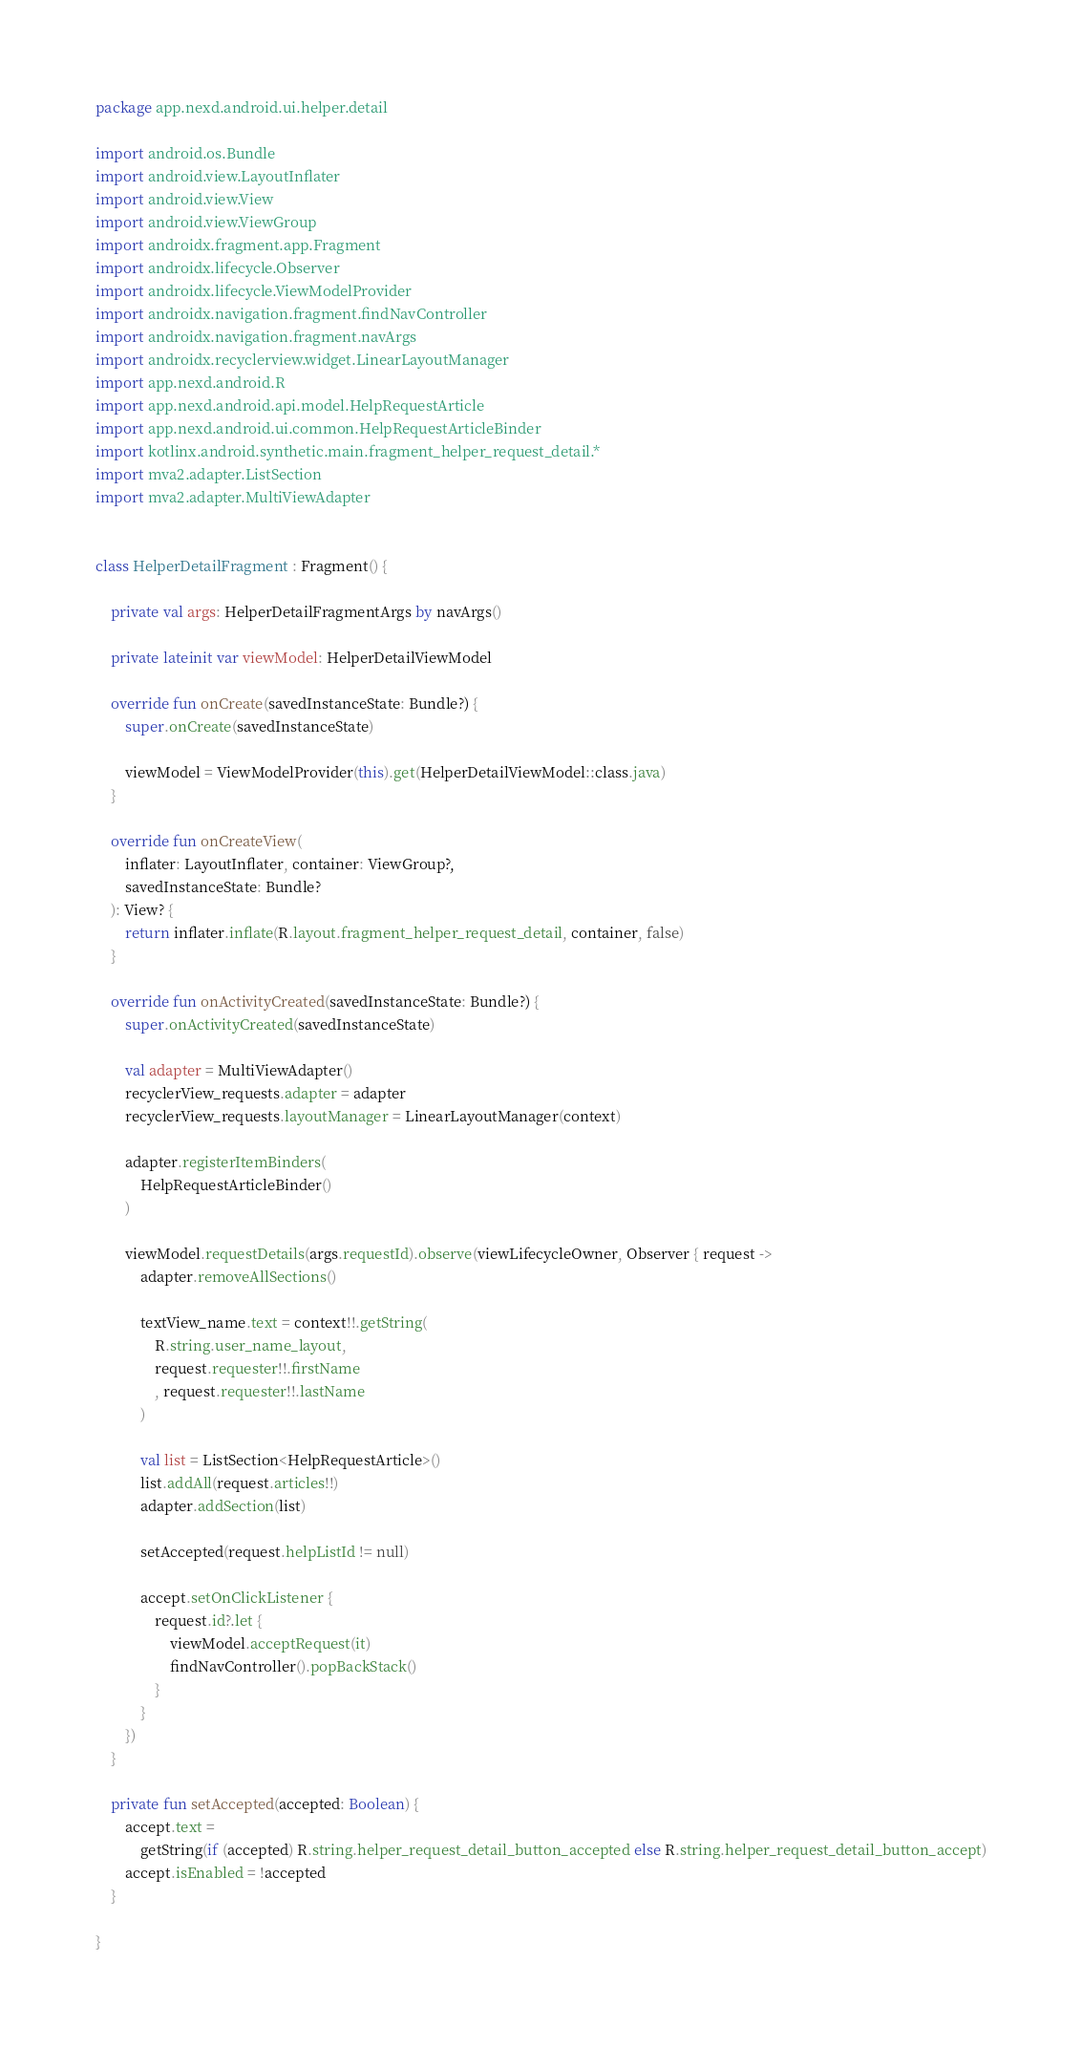<code> <loc_0><loc_0><loc_500><loc_500><_Kotlin_>package app.nexd.android.ui.helper.detail

import android.os.Bundle
import android.view.LayoutInflater
import android.view.View
import android.view.ViewGroup
import androidx.fragment.app.Fragment
import androidx.lifecycle.Observer
import androidx.lifecycle.ViewModelProvider
import androidx.navigation.fragment.findNavController
import androidx.navigation.fragment.navArgs
import androidx.recyclerview.widget.LinearLayoutManager
import app.nexd.android.R
import app.nexd.android.api.model.HelpRequestArticle
import app.nexd.android.ui.common.HelpRequestArticleBinder
import kotlinx.android.synthetic.main.fragment_helper_request_detail.*
import mva2.adapter.ListSection
import mva2.adapter.MultiViewAdapter


class HelperDetailFragment : Fragment() {

    private val args: HelperDetailFragmentArgs by navArgs()

    private lateinit var viewModel: HelperDetailViewModel

    override fun onCreate(savedInstanceState: Bundle?) {
        super.onCreate(savedInstanceState)

        viewModel = ViewModelProvider(this).get(HelperDetailViewModel::class.java)
    }

    override fun onCreateView(
        inflater: LayoutInflater, container: ViewGroup?,
        savedInstanceState: Bundle?
    ): View? {
        return inflater.inflate(R.layout.fragment_helper_request_detail, container, false)
    }

    override fun onActivityCreated(savedInstanceState: Bundle?) {
        super.onActivityCreated(savedInstanceState)

        val adapter = MultiViewAdapter()
        recyclerView_requests.adapter = adapter
        recyclerView_requests.layoutManager = LinearLayoutManager(context)

        adapter.registerItemBinders(
            HelpRequestArticleBinder()
        )

        viewModel.requestDetails(args.requestId).observe(viewLifecycleOwner, Observer { request ->
            adapter.removeAllSections()

            textView_name.text = context!!.getString(
                R.string.user_name_layout,
                request.requester!!.firstName
                , request.requester!!.lastName
            )

            val list = ListSection<HelpRequestArticle>()
            list.addAll(request.articles!!)
            adapter.addSection(list)

            setAccepted(request.helpListId != null)

            accept.setOnClickListener {
                request.id?.let {
                    viewModel.acceptRequest(it)
                    findNavController().popBackStack()
                }
            }
        })
    }

    private fun setAccepted(accepted: Boolean) {
        accept.text =
            getString(if (accepted) R.string.helper_request_detail_button_accepted else R.string.helper_request_detail_button_accept)
        accept.isEnabled = !accepted
    }

}
</code> 